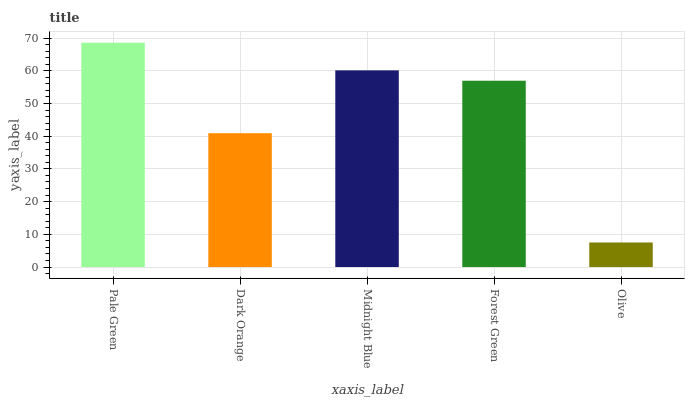Is Olive the minimum?
Answer yes or no. Yes. Is Pale Green the maximum?
Answer yes or no. Yes. Is Dark Orange the minimum?
Answer yes or no. No. Is Dark Orange the maximum?
Answer yes or no. No. Is Pale Green greater than Dark Orange?
Answer yes or no. Yes. Is Dark Orange less than Pale Green?
Answer yes or no. Yes. Is Dark Orange greater than Pale Green?
Answer yes or no. No. Is Pale Green less than Dark Orange?
Answer yes or no. No. Is Forest Green the high median?
Answer yes or no. Yes. Is Forest Green the low median?
Answer yes or no. Yes. Is Olive the high median?
Answer yes or no. No. Is Midnight Blue the low median?
Answer yes or no. No. 